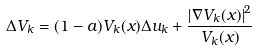<formula> <loc_0><loc_0><loc_500><loc_500>\Delta V _ { k } = ( 1 - a ) V _ { k } ( x ) \Delta u _ { k } + \frac { \left | \nabla V _ { k } ( x ) \right | ^ { 2 } } { V _ { k } ( x ) }</formula> 